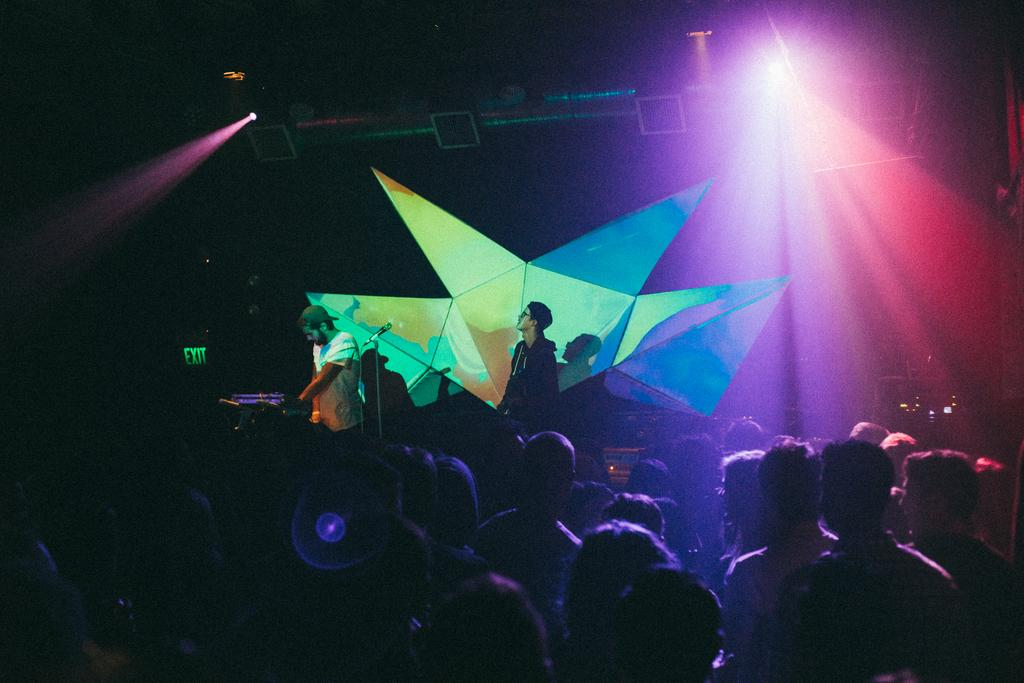How many people are in the image? There is a group of people in the image. What are two of the people doing in the image? Two persons are standing in the image. What object is used for amplifying sound in the image? There is a microphone with a microphone stand in the image. What type of lighting is present in the image? There are focus lights in the image. What is the flat, rectangular object in the image? There is a board in the image. What type of beef is being served on the board in the image? There is no beef present in the image; the board is not related to food. 